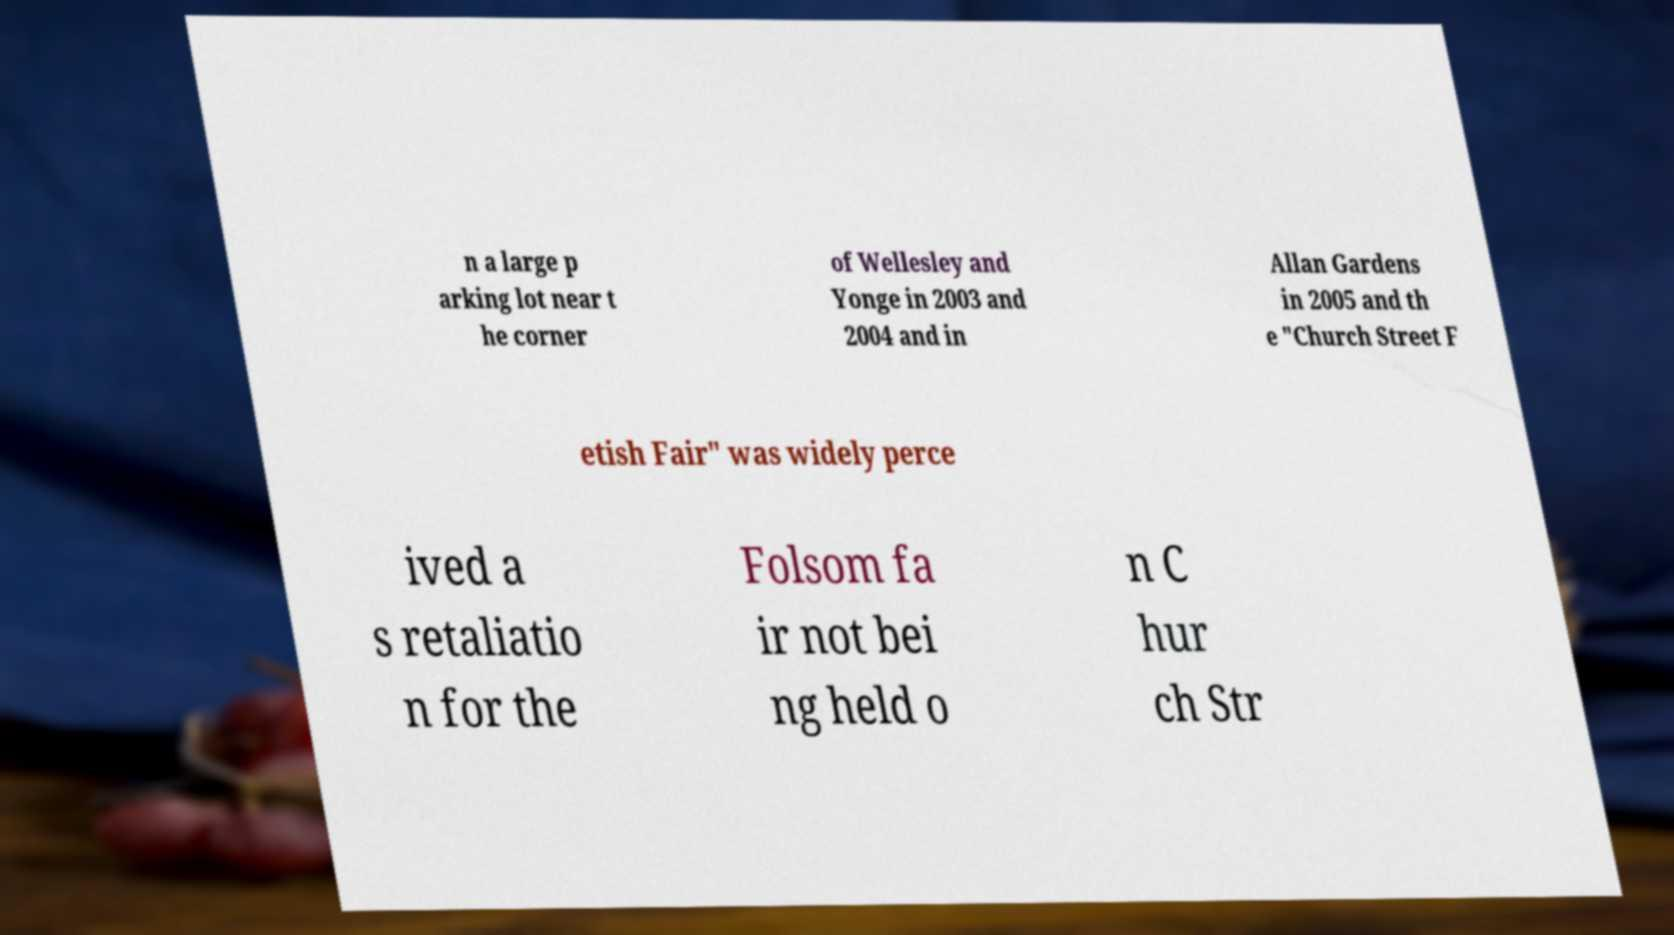Could you extract and type out the text from this image? n a large p arking lot near t he corner of Wellesley and Yonge in 2003 and 2004 and in Allan Gardens in 2005 and th e "Church Street F etish Fair" was widely perce ived a s retaliatio n for the Folsom fa ir not bei ng held o n C hur ch Str 